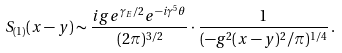Convert formula to latex. <formula><loc_0><loc_0><loc_500><loc_500>S _ { ( 1 ) } ( x - y ) \sim \frac { i g e ^ { \gamma _ { E } / 2 } e ^ { - i \gamma ^ { 5 } \theta } } { ( 2 \pi ) ^ { 3 / 2 } } \cdot \frac { 1 } { ( - g ^ { 2 } ( x - y ) ^ { 2 } / \pi ) ^ { 1 / 4 } } \, .</formula> 